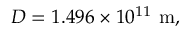<formula> <loc_0><loc_0><loc_500><loc_500>D = 1 . 4 9 6 \times 1 0 ^ { 1 1 } \ m ,</formula> 